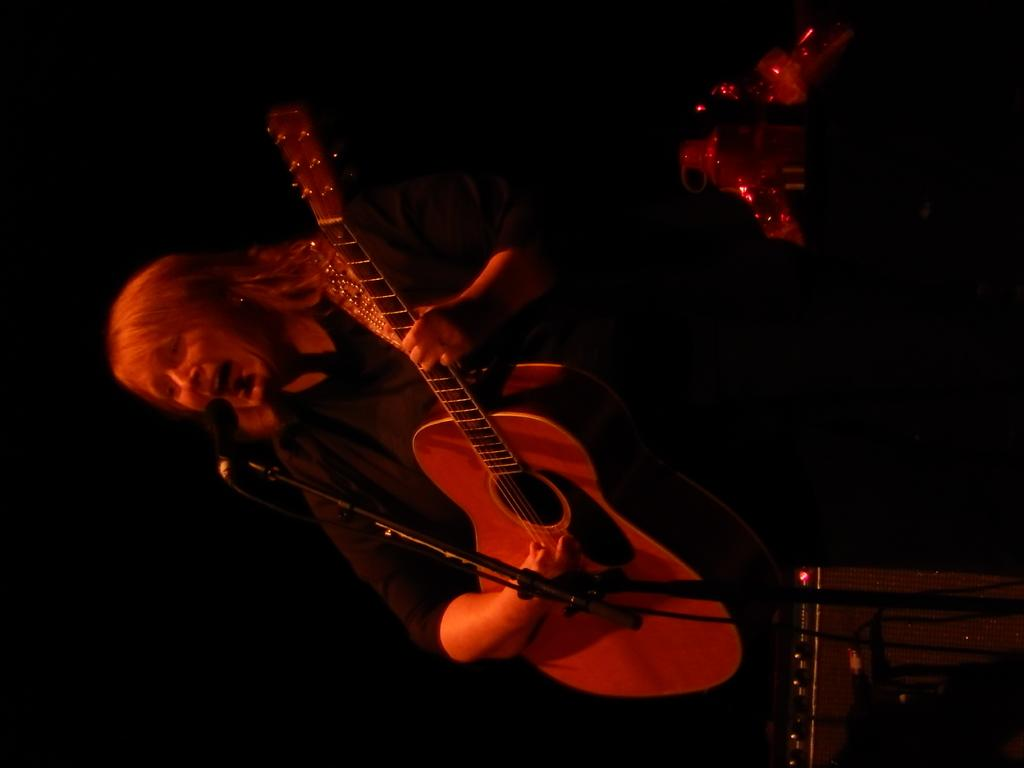What is the main subject of the image? The main subject of the image is a woman. What is the woman doing in the image? The woman is standing and playing a guitar. What advice does the woman's grandfather give her during her journey in the image? There is no mention of a journey or a grandfather in the image; it only shows a woman standing and playing a guitar. 